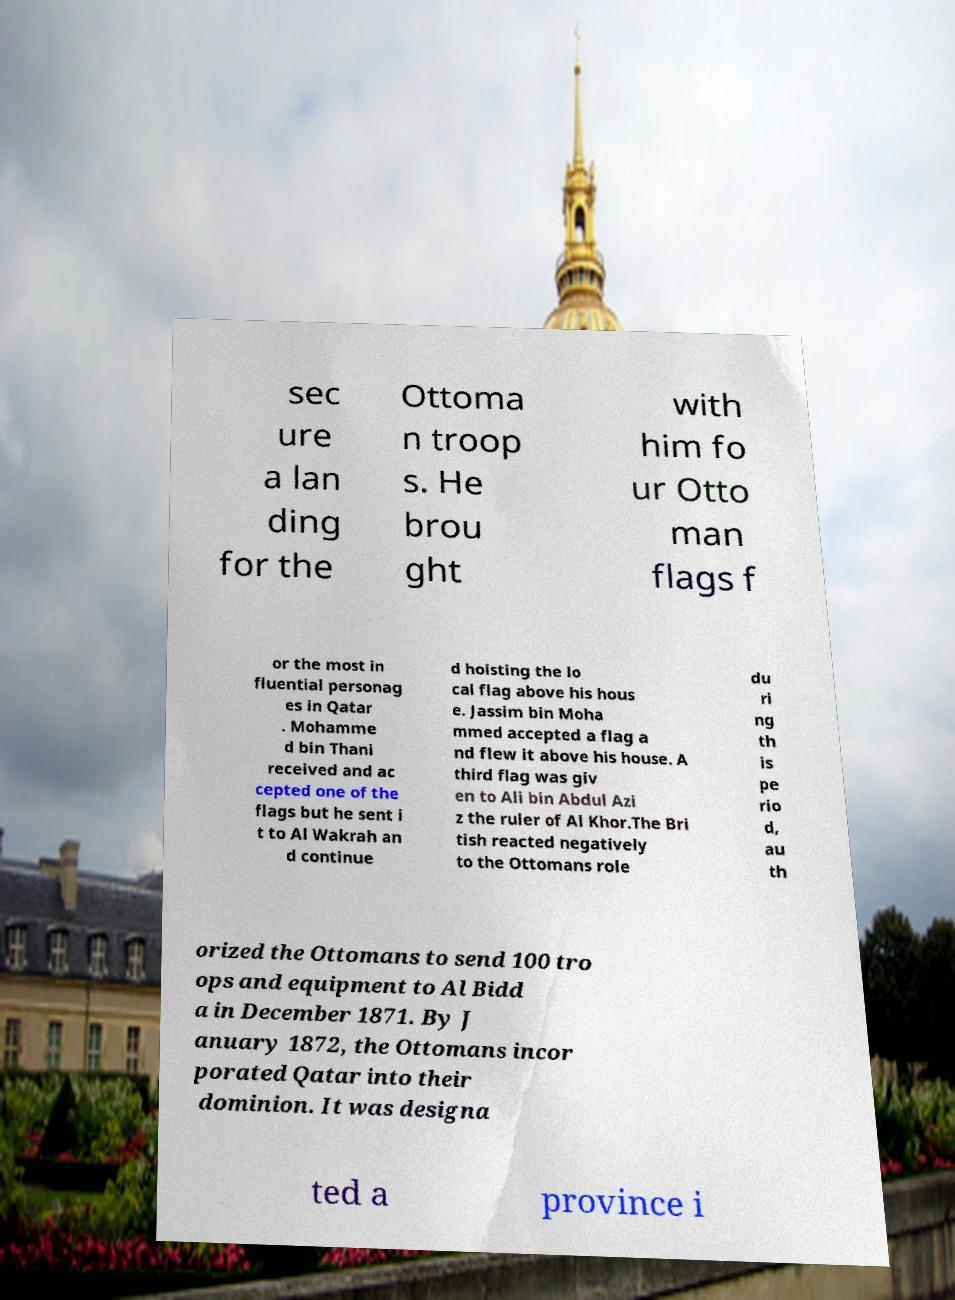Can you read and provide the text displayed in the image?This photo seems to have some interesting text. Can you extract and type it out for me? sec ure a lan ding for the Ottoma n troop s. He brou ght with him fo ur Otto man flags f or the most in fluential personag es in Qatar . Mohamme d bin Thani received and ac cepted one of the flags but he sent i t to Al Wakrah an d continue d hoisting the lo cal flag above his hous e. Jassim bin Moha mmed accepted a flag a nd flew it above his house. A third flag was giv en to Ali bin Abdul Azi z the ruler of Al Khor.The Bri tish reacted negatively to the Ottomans role du ri ng th is pe rio d, au th orized the Ottomans to send 100 tro ops and equipment to Al Bidd a in December 1871. By J anuary 1872, the Ottomans incor porated Qatar into their dominion. It was designa ted a province i 